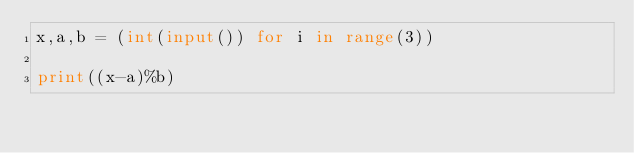Convert code to text. <code><loc_0><loc_0><loc_500><loc_500><_Python_>x,a,b = (int(input()) for i in range(3))

print((x-a)%b)
</code> 